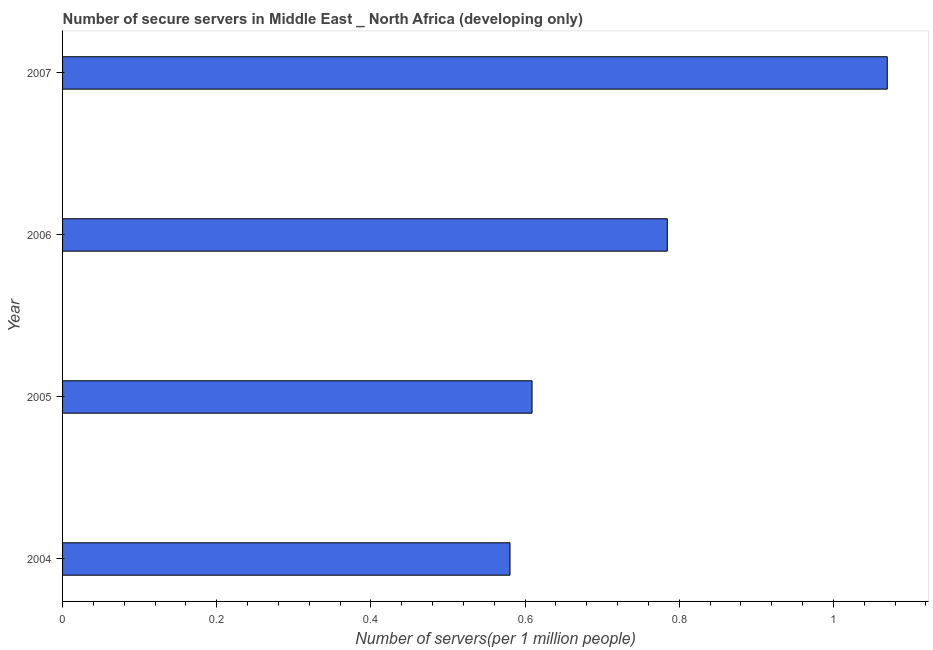Does the graph contain grids?
Keep it short and to the point. No. What is the title of the graph?
Keep it short and to the point. Number of secure servers in Middle East _ North Africa (developing only). What is the label or title of the X-axis?
Your answer should be very brief. Number of servers(per 1 million people). What is the number of secure internet servers in 2004?
Keep it short and to the point. 0.58. Across all years, what is the maximum number of secure internet servers?
Provide a short and direct response. 1.07. Across all years, what is the minimum number of secure internet servers?
Offer a very short reply. 0.58. What is the sum of the number of secure internet servers?
Give a very brief answer. 3.04. What is the difference between the number of secure internet servers in 2004 and 2005?
Your answer should be very brief. -0.03. What is the average number of secure internet servers per year?
Your answer should be very brief. 0.76. What is the median number of secure internet servers?
Provide a succinct answer. 0.7. What is the ratio of the number of secure internet servers in 2004 to that in 2005?
Offer a very short reply. 0.95. Is the difference between the number of secure internet servers in 2004 and 2005 greater than the difference between any two years?
Keep it short and to the point. No. What is the difference between the highest and the second highest number of secure internet servers?
Your answer should be compact. 0.28. What is the difference between the highest and the lowest number of secure internet servers?
Your response must be concise. 0.49. How many bars are there?
Make the answer very short. 4. Are all the bars in the graph horizontal?
Your response must be concise. Yes. How many years are there in the graph?
Your answer should be very brief. 4. What is the difference between two consecutive major ticks on the X-axis?
Offer a terse response. 0.2. What is the Number of servers(per 1 million people) of 2004?
Your response must be concise. 0.58. What is the Number of servers(per 1 million people) of 2005?
Give a very brief answer. 0.61. What is the Number of servers(per 1 million people) of 2006?
Your answer should be compact. 0.78. What is the Number of servers(per 1 million people) of 2007?
Offer a terse response. 1.07. What is the difference between the Number of servers(per 1 million people) in 2004 and 2005?
Provide a succinct answer. -0.03. What is the difference between the Number of servers(per 1 million people) in 2004 and 2006?
Provide a short and direct response. -0.2. What is the difference between the Number of servers(per 1 million people) in 2004 and 2007?
Your answer should be compact. -0.49. What is the difference between the Number of servers(per 1 million people) in 2005 and 2006?
Make the answer very short. -0.18. What is the difference between the Number of servers(per 1 million people) in 2005 and 2007?
Provide a succinct answer. -0.46. What is the difference between the Number of servers(per 1 million people) in 2006 and 2007?
Your answer should be compact. -0.29. What is the ratio of the Number of servers(per 1 million people) in 2004 to that in 2005?
Offer a terse response. 0.95. What is the ratio of the Number of servers(per 1 million people) in 2004 to that in 2006?
Your response must be concise. 0.74. What is the ratio of the Number of servers(per 1 million people) in 2004 to that in 2007?
Your answer should be very brief. 0.54. What is the ratio of the Number of servers(per 1 million people) in 2005 to that in 2006?
Provide a succinct answer. 0.78. What is the ratio of the Number of servers(per 1 million people) in 2005 to that in 2007?
Make the answer very short. 0.57. What is the ratio of the Number of servers(per 1 million people) in 2006 to that in 2007?
Your answer should be very brief. 0.73. 